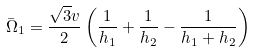Convert formula to latex. <formula><loc_0><loc_0><loc_500><loc_500>\bar { \Omega } _ { 1 } = \frac { \sqrt { 3 } v } { 2 } \left ( \frac { 1 } { h _ { 1 } } + \frac { 1 } { h _ { 2 } } - \frac { 1 } { h _ { 1 } + h _ { 2 } } \right )</formula> 